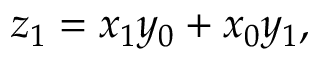Convert formula to latex. <formula><loc_0><loc_0><loc_500><loc_500>z _ { 1 } = x _ { 1 } y _ { 0 } + x _ { 0 } y _ { 1 } ,</formula> 